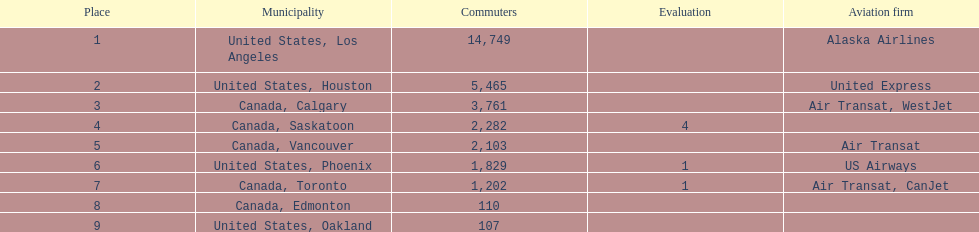What was the number of passengers in phoenix arizona? 1,829. 